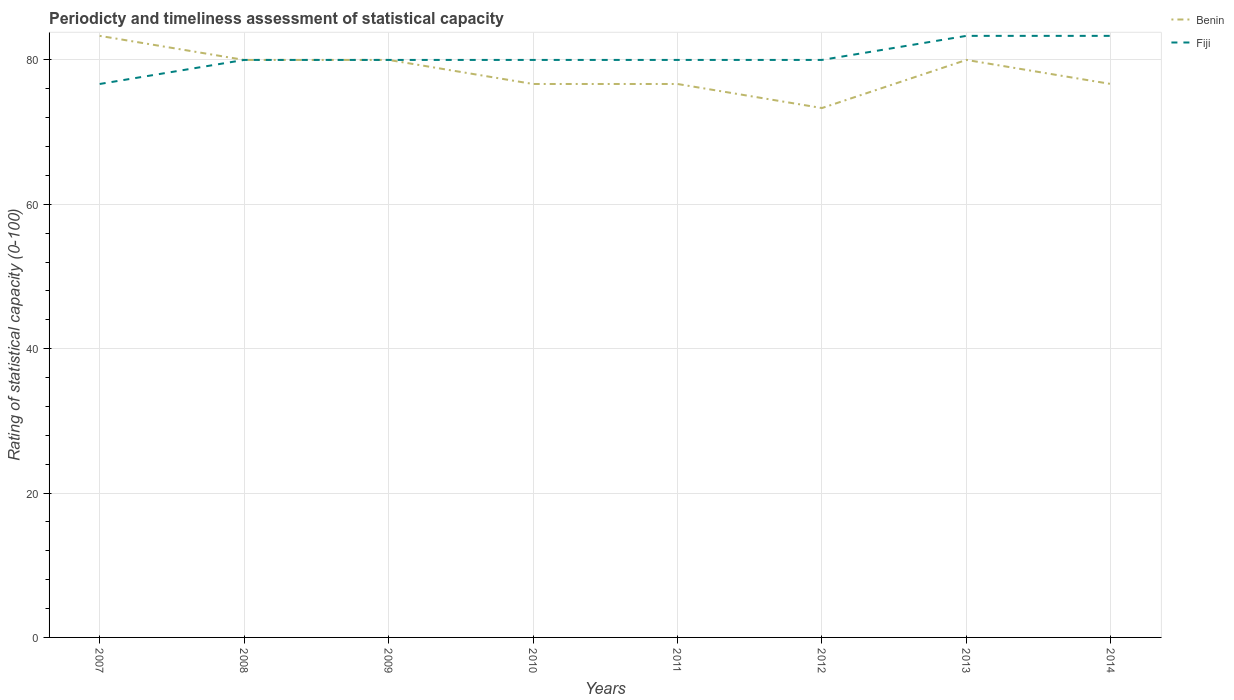How many different coloured lines are there?
Provide a short and direct response. 2. Does the line corresponding to Benin intersect with the line corresponding to Fiji?
Give a very brief answer. Yes. Is the number of lines equal to the number of legend labels?
Your answer should be compact. Yes. Across all years, what is the maximum rating of statistical capacity in Benin?
Offer a terse response. 73.33. In which year was the rating of statistical capacity in Benin maximum?
Your answer should be very brief. 2012. What is the total rating of statistical capacity in Fiji in the graph?
Give a very brief answer. -3.33. What is the difference between the highest and the second highest rating of statistical capacity in Fiji?
Your answer should be very brief. 6.67. What is the difference between the highest and the lowest rating of statistical capacity in Fiji?
Provide a short and direct response. 2. Is the rating of statistical capacity in Benin strictly greater than the rating of statistical capacity in Fiji over the years?
Your answer should be compact. No. How many years are there in the graph?
Offer a terse response. 8. What is the difference between two consecutive major ticks on the Y-axis?
Offer a terse response. 20. Are the values on the major ticks of Y-axis written in scientific E-notation?
Your response must be concise. No. Does the graph contain grids?
Offer a terse response. Yes. Where does the legend appear in the graph?
Your response must be concise. Top right. How are the legend labels stacked?
Your answer should be very brief. Vertical. What is the title of the graph?
Your answer should be very brief. Periodicty and timeliness assessment of statistical capacity. What is the label or title of the Y-axis?
Give a very brief answer. Rating of statistical capacity (0-100). What is the Rating of statistical capacity (0-100) in Benin in 2007?
Make the answer very short. 83.33. What is the Rating of statistical capacity (0-100) of Fiji in 2007?
Your answer should be compact. 76.67. What is the Rating of statistical capacity (0-100) in Benin in 2010?
Ensure brevity in your answer.  76.67. What is the Rating of statistical capacity (0-100) in Fiji in 2010?
Provide a succinct answer. 80. What is the Rating of statistical capacity (0-100) of Benin in 2011?
Your answer should be very brief. 76.67. What is the Rating of statistical capacity (0-100) of Fiji in 2011?
Give a very brief answer. 80. What is the Rating of statistical capacity (0-100) in Benin in 2012?
Provide a short and direct response. 73.33. What is the Rating of statistical capacity (0-100) in Fiji in 2013?
Ensure brevity in your answer.  83.33. What is the Rating of statistical capacity (0-100) of Benin in 2014?
Your response must be concise. 76.67. What is the Rating of statistical capacity (0-100) of Fiji in 2014?
Make the answer very short. 83.33. Across all years, what is the maximum Rating of statistical capacity (0-100) of Benin?
Give a very brief answer. 83.33. Across all years, what is the maximum Rating of statistical capacity (0-100) in Fiji?
Keep it short and to the point. 83.33. Across all years, what is the minimum Rating of statistical capacity (0-100) in Benin?
Your answer should be compact. 73.33. Across all years, what is the minimum Rating of statistical capacity (0-100) in Fiji?
Your response must be concise. 76.67. What is the total Rating of statistical capacity (0-100) of Benin in the graph?
Make the answer very short. 626.67. What is the total Rating of statistical capacity (0-100) of Fiji in the graph?
Make the answer very short. 643.33. What is the difference between the Rating of statistical capacity (0-100) of Fiji in 2007 and that in 2010?
Provide a short and direct response. -3.33. What is the difference between the Rating of statistical capacity (0-100) in Fiji in 2007 and that in 2011?
Ensure brevity in your answer.  -3.33. What is the difference between the Rating of statistical capacity (0-100) of Benin in 2007 and that in 2012?
Your answer should be very brief. 10. What is the difference between the Rating of statistical capacity (0-100) in Fiji in 2007 and that in 2013?
Ensure brevity in your answer.  -6.67. What is the difference between the Rating of statistical capacity (0-100) in Fiji in 2007 and that in 2014?
Offer a terse response. -6.67. What is the difference between the Rating of statistical capacity (0-100) in Benin in 2008 and that in 2010?
Your answer should be compact. 3.33. What is the difference between the Rating of statistical capacity (0-100) of Benin in 2008 and that in 2011?
Offer a very short reply. 3.33. What is the difference between the Rating of statistical capacity (0-100) in Benin in 2008 and that in 2014?
Keep it short and to the point. 3.33. What is the difference between the Rating of statistical capacity (0-100) in Fiji in 2009 and that in 2010?
Your answer should be very brief. 0. What is the difference between the Rating of statistical capacity (0-100) of Fiji in 2009 and that in 2011?
Your answer should be compact. 0. What is the difference between the Rating of statistical capacity (0-100) of Benin in 2009 and that in 2012?
Provide a short and direct response. 6.67. What is the difference between the Rating of statistical capacity (0-100) in Fiji in 2009 and that in 2012?
Your response must be concise. 0. What is the difference between the Rating of statistical capacity (0-100) in Benin in 2009 and that in 2013?
Offer a terse response. 0. What is the difference between the Rating of statistical capacity (0-100) of Fiji in 2009 and that in 2014?
Give a very brief answer. -3.33. What is the difference between the Rating of statistical capacity (0-100) of Benin in 2010 and that in 2011?
Provide a succinct answer. 0. What is the difference between the Rating of statistical capacity (0-100) of Fiji in 2010 and that in 2011?
Offer a terse response. 0. What is the difference between the Rating of statistical capacity (0-100) in Benin in 2010 and that in 2012?
Offer a very short reply. 3.33. What is the difference between the Rating of statistical capacity (0-100) in Fiji in 2010 and that in 2012?
Offer a terse response. 0. What is the difference between the Rating of statistical capacity (0-100) of Benin in 2010 and that in 2013?
Your answer should be compact. -3.33. What is the difference between the Rating of statistical capacity (0-100) of Fiji in 2010 and that in 2013?
Offer a very short reply. -3.33. What is the difference between the Rating of statistical capacity (0-100) of Benin in 2010 and that in 2014?
Ensure brevity in your answer.  0. What is the difference between the Rating of statistical capacity (0-100) of Fiji in 2010 and that in 2014?
Offer a very short reply. -3.33. What is the difference between the Rating of statistical capacity (0-100) of Benin in 2011 and that in 2012?
Your response must be concise. 3.33. What is the difference between the Rating of statistical capacity (0-100) in Benin in 2011 and that in 2013?
Your answer should be compact. -3.33. What is the difference between the Rating of statistical capacity (0-100) in Fiji in 2011 and that in 2013?
Offer a terse response. -3.33. What is the difference between the Rating of statistical capacity (0-100) in Benin in 2011 and that in 2014?
Provide a short and direct response. 0. What is the difference between the Rating of statistical capacity (0-100) of Benin in 2012 and that in 2013?
Keep it short and to the point. -6.67. What is the difference between the Rating of statistical capacity (0-100) in Benin in 2013 and that in 2014?
Offer a terse response. 3.33. What is the difference between the Rating of statistical capacity (0-100) in Benin in 2007 and the Rating of statistical capacity (0-100) in Fiji in 2008?
Your answer should be very brief. 3.33. What is the difference between the Rating of statistical capacity (0-100) in Benin in 2007 and the Rating of statistical capacity (0-100) in Fiji in 2009?
Keep it short and to the point. 3.33. What is the difference between the Rating of statistical capacity (0-100) in Benin in 2007 and the Rating of statistical capacity (0-100) in Fiji in 2010?
Offer a very short reply. 3.33. What is the difference between the Rating of statistical capacity (0-100) of Benin in 2007 and the Rating of statistical capacity (0-100) of Fiji in 2012?
Provide a short and direct response. 3.33. What is the difference between the Rating of statistical capacity (0-100) in Benin in 2007 and the Rating of statistical capacity (0-100) in Fiji in 2013?
Provide a short and direct response. -0. What is the difference between the Rating of statistical capacity (0-100) of Benin in 2007 and the Rating of statistical capacity (0-100) of Fiji in 2014?
Offer a very short reply. -0. What is the difference between the Rating of statistical capacity (0-100) of Benin in 2008 and the Rating of statistical capacity (0-100) of Fiji in 2009?
Ensure brevity in your answer.  0. What is the difference between the Rating of statistical capacity (0-100) of Benin in 2008 and the Rating of statistical capacity (0-100) of Fiji in 2011?
Ensure brevity in your answer.  0. What is the difference between the Rating of statistical capacity (0-100) of Benin in 2008 and the Rating of statistical capacity (0-100) of Fiji in 2012?
Provide a short and direct response. 0. What is the difference between the Rating of statistical capacity (0-100) in Benin in 2009 and the Rating of statistical capacity (0-100) in Fiji in 2010?
Your answer should be very brief. 0. What is the difference between the Rating of statistical capacity (0-100) in Benin in 2009 and the Rating of statistical capacity (0-100) in Fiji in 2011?
Make the answer very short. 0. What is the difference between the Rating of statistical capacity (0-100) in Benin in 2009 and the Rating of statistical capacity (0-100) in Fiji in 2013?
Make the answer very short. -3.33. What is the difference between the Rating of statistical capacity (0-100) in Benin in 2009 and the Rating of statistical capacity (0-100) in Fiji in 2014?
Ensure brevity in your answer.  -3.33. What is the difference between the Rating of statistical capacity (0-100) of Benin in 2010 and the Rating of statistical capacity (0-100) of Fiji in 2013?
Offer a terse response. -6.67. What is the difference between the Rating of statistical capacity (0-100) in Benin in 2010 and the Rating of statistical capacity (0-100) in Fiji in 2014?
Your answer should be very brief. -6.67. What is the difference between the Rating of statistical capacity (0-100) of Benin in 2011 and the Rating of statistical capacity (0-100) of Fiji in 2012?
Your response must be concise. -3.33. What is the difference between the Rating of statistical capacity (0-100) of Benin in 2011 and the Rating of statistical capacity (0-100) of Fiji in 2013?
Offer a very short reply. -6.67. What is the difference between the Rating of statistical capacity (0-100) in Benin in 2011 and the Rating of statistical capacity (0-100) in Fiji in 2014?
Keep it short and to the point. -6.67. What is the average Rating of statistical capacity (0-100) in Benin per year?
Keep it short and to the point. 78.33. What is the average Rating of statistical capacity (0-100) in Fiji per year?
Your answer should be compact. 80.42. In the year 2007, what is the difference between the Rating of statistical capacity (0-100) in Benin and Rating of statistical capacity (0-100) in Fiji?
Provide a short and direct response. 6.67. In the year 2009, what is the difference between the Rating of statistical capacity (0-100) in Benin and Rating of statistical capacity (0-100) in Fiji?
Keep it short and to the point. 0. In the year 2012, what is the difference between the Rating of statistical capacity (0-100) in Benin and Rating of statistical capacity (0-100) in Fiji?
Offer a terse response. -6.67. In the year 2014, what is the difference between the Rating of statistical capacity (0-100) in Benin and Rating of statistical capacity (0-100) in Fiji?
Your answer should be compact. -6.67. What is the ratio of the Rating of statistical capacity (0-100) in Benin in 2007 to that in 2008?
Provide a succinct answer. 1.04. What is the ratio of the Rating of statistical capacity (0-100) of Benin in 2007 to that in 2009?
Your response must be concise. 1.04. What is the ratio of the Rating of statistical capacity (0-100) of Benin in 2007 to that in 2010?
Provide a short and direct response. 1.09. What is the ratio of the Rating of statistical capacity (0-100) of Fiji in 2007 to that in 2010?
Give a very brief answer. 0.96. What is the ratio of the Rating of statistical capacity (0-100) of Benin in 2007 to that in 2011?
Provide a succinct answer. 1.09. What is the ratio of the Rating of statistical capacity (0-100) in Benin in 2007 to that in 2012?
Make the answer very short. 1.14. What is the ratio of the Rating of statistical capacity (0-100) of Benin in 2007 to that in 2013?
Your answer should be compact. 1.04. What is the ratio of the Rating of statistical capacity (0-100) of Benin in 2007 to that in 2014?
Give a very brief answer. 1.09. What is the ratio of the Rating of statistical capacity (0-100) in Benin in 2008 to that in 2010?
Provide a succinct answer. 1.04. What is the ratio of the Rating of statistical capacity (0-100) of Benin in 2008 to that in 2011?
Your answer should be compact. 1.04. What is the ratio of the Rating of statistical capacity (0-100) of Fiji in 2008 to that in 2011?
Your response must be concise. 1. What is the ratio of the Rating of statistical capacity (0-100) in Benin in 2008 to that in 2012?
Make the answer very short. 1.09. What is the ratio of the Rating of statistical capacity (0-100) of Fiji in 2008 to that in 2012?
Provide a succinct answer. 1. What is the ratio of the Rating of statistical capacity (0-100) in Benin in 2008 to that in 2013?
Your response must be concise. 1. What is the ratio of the Rating of statistical capacity (0-100) of Benin in 2008 to that in 2014?
Provide a short and direct response. 1.04. What is the ratio of the Rating of statistical capacity (0-100) in Benin in 2009 to that in 2010?
Your answer should be compact. 1.04. What is the ratio of the Rating of statistical capacity (0-100) of Benin in 2009 to that in 2011?
Offer a very short reply. 1.04. What is the ratio of the Rating of statistical capacity (0-100) in Benin in 2009 to that in 2012?
Your response must be concise. 1.09. What is the ratio of the Rating of statistical capacity (0-100) of Benin in 2009 to that in 2013?
Keep it short and to the point. 1. What is the ratio of the Rating of statistical capacity (0-100) of Fiji in 2009 to that in 2013?
Give a very brief answer. 0.96. What is the ratio of the Rating of statistical capacity (0-100) of Benin in 2009 to that in 2014?
Your answer should be very brief. 1.04. What is the ratio of the Rating of statistical capacity (0-100) of Fiji in 2010 to that in 2011?
Your answer should be very brief. 1. What is the ratio of the Rating of statistical capacity (0-100) in Benin in 2010 to that in 2012?
Your answer should be compact. 1.05. What is the ratio of the Rating of statistical capacity (0-100) of Fiji in 2010 to that in 2012?
Provide a succinct answer. 1. What is the ratio of the Rating of statistical capacity (0-100) of Fiji in 2010 to that in 2014?
Offer a terse response. 0.96. What is the ratio of the Rating of statistical capacity (0-100) of Benin in 2011 to that in 2012?
Your response must be concise. 1.05. What is the ratio of the Rating of statistical capacity (0-100) of Fiji in 2011 to that in 2012?
Give a very brief answer. 1. What is the ratio of the Rating of statistical capacity (0-100) in Benin in 2011 to that in 2014?
Provide a succinct answer. 1. What is the ratio of the Rating of statistical capacity (0-100) in Fiji in 2011 to that in 2014?
Your answer should be compact. 0.96. What is the ratio of the Rating of statistical capacity (0-100) of Benin in 2012 to that in 2013?
Provide a short and direct response. 0.92. What is the ratio of the Rating of statistical capacity (0-100) of Fiji in 2012 to that in 2013?
Offer a very short reply. 0.96. What is the ratio of the Rating of statistical capacity (0-100) of Benin in 2012 to that in 2014?
Your answer should be compact. 0.96. What is the ratio of the Rating of statistical capacity (0-100) of Fiji in 2012 to that in 2014?
Your response must be concise. 0.96. What is the ratio of the Rating of statistical capacity (0-100) in Benin in 2013 to that in 2014?
Your answer should be compact. 1.04. What is the difference between the highest and the second highest Rating of statistical capacity (0-100) in Benin?
Offer a terse response. 3.33. What is the difference between the highest and the second highest Rating of statistical capacity (0-100) in Fiji?
Give a very brief answer. 0. What is the difference between the highest and the lowest Rating of statistical capacity (0-100) in Fiji?
Offer a terse response. 6.67. 